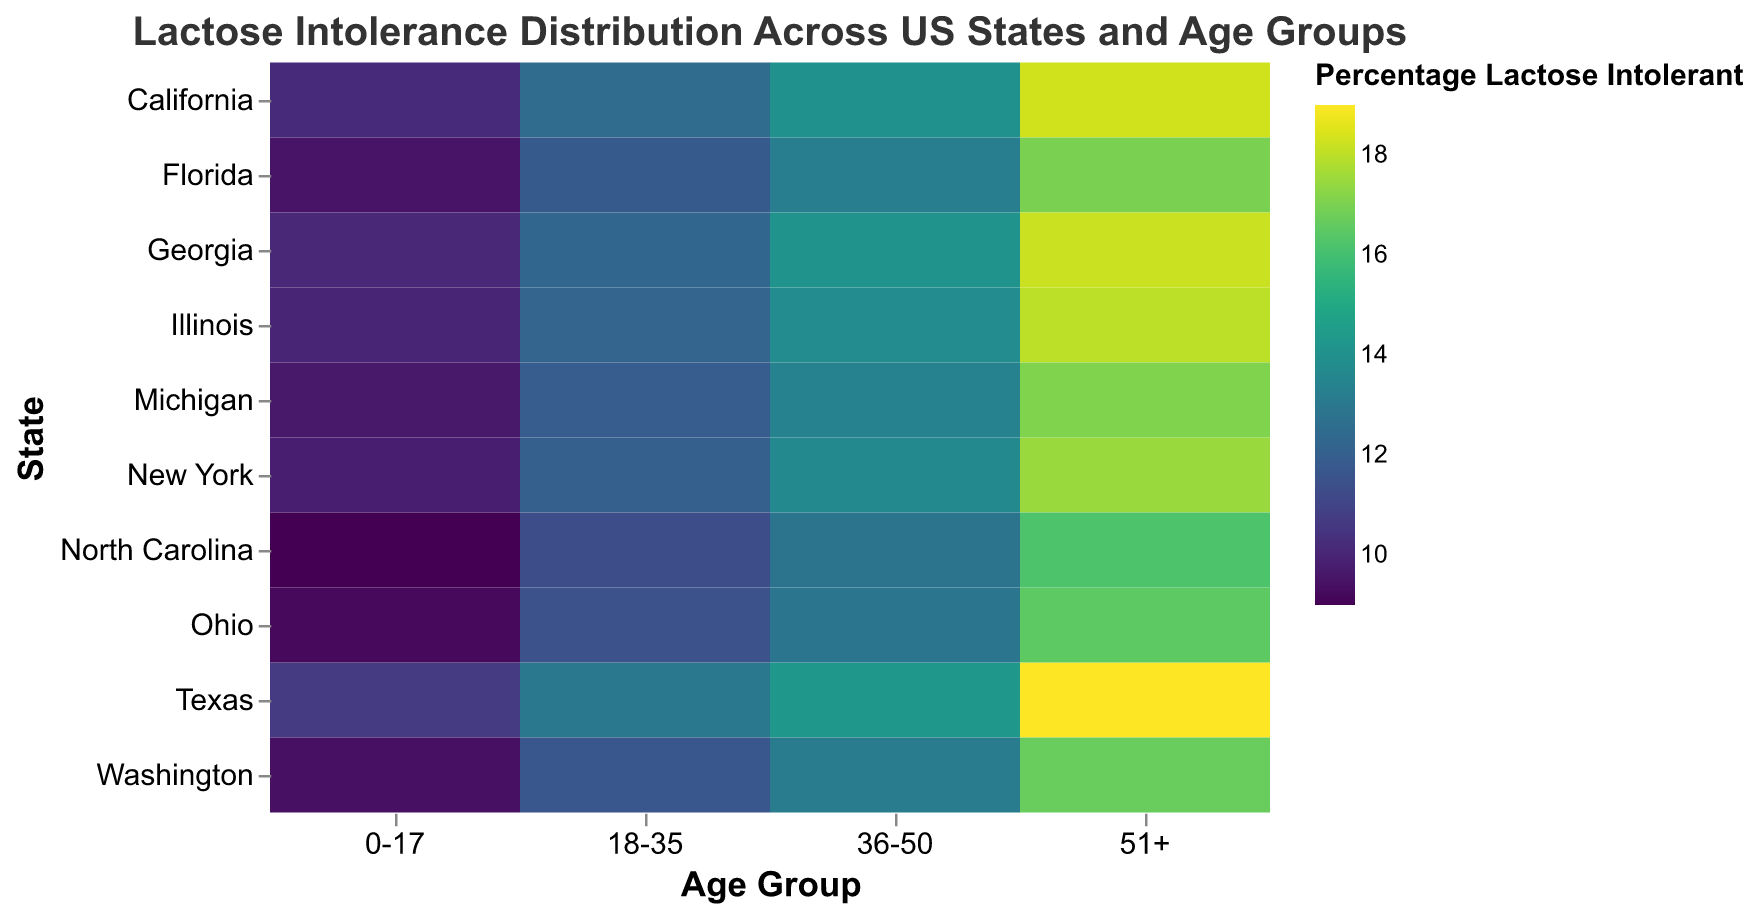What is the percentage of lactose intolerance in the 51+ age group in California? Locate California on the y-axis and the 51+ age group on the x-axis. Find the intersection and read the color's legend value.
Answer: 18.3 Which state has the highest percentage of lactose intolerance in the 0-17 age group? Find the 0-17 age group on the x-axis, then move along the column to identify the state with the highest percentage based on the color intensity.
Answer: Texas What is the difference in lactose intolerance percentage between the 0-17 and 51+ age groups in Florida? Locate Florida on the y-axis, then find the percentages for the 0-17 and 51+ age groups (9.5 and 17.0). Subtract the smaller from the larger.
Answer: 7.5 Which age group has the highest average percentage of lactose intolerance across all states? Calculate the average lactose intolerance percentage for each age group by summing the percentages across states and dividing by the number of states (10). Compare these averages.
Answer: 51+ What is the common pattern of lactose intolerance percentages across age groups in most states? Trace the percentages across age groups for multiple states. Notice that the percentage generally increases with age.
Answer: Increases with age Which state shows a consistent increase in lactose intolerance percentage with age? Examine each state’s row to identify any state where the percentage increases uniformly from the youngest to the oldest age group.
Answer: California Is there any state where the lactose intolerance percentage for the 36-50 age group is less than 50% of the percentage of the 18-35 age group? Compare the percentages for each state’s 36-50 and 18-35 age groups, checking the condition. No state meets this criterion.
Answer: No What is the percentage of lactose intolerance for the 36-50 age group in Georgia? Locate Georgia on the y-axis and the 36-50 age group on the x-axis. Find the intersection and read the value.
Answer: 14.1 Which state has the lowest percentage of lactose intolerance in the 18-35 age group? Find the 18-35 age group on the x-axis, then move along the column to identify the state with the lowest percentage based on the color tone.
Answer: North Carolina Does any state have a lactose intolerance percentage in the 51+ age group exceeding 18%? Check the 51+ age group column for any state with a percentage greater than 18%. Identify that Texas, California, and Georgia meet the criterion.
Answer: Yes 